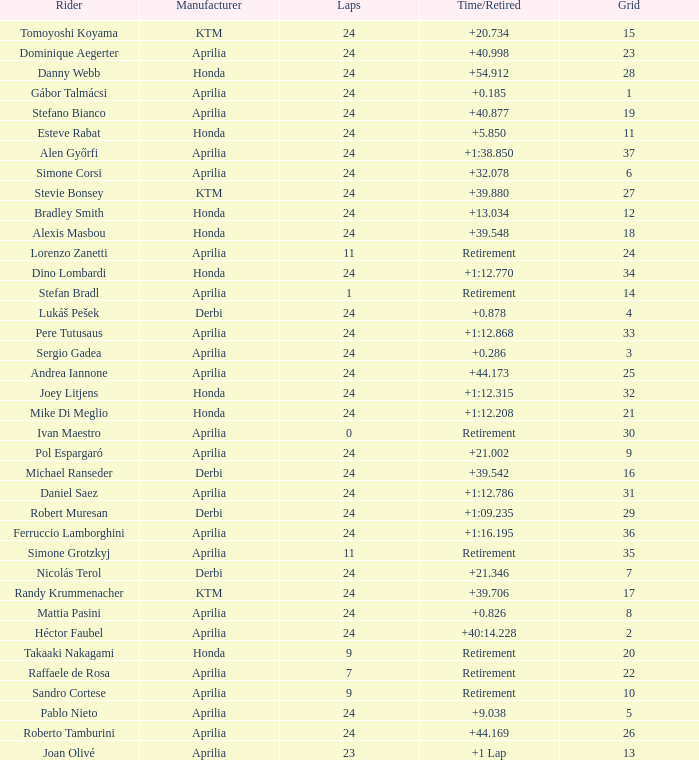What is the time with 10 grids? Retirement. 